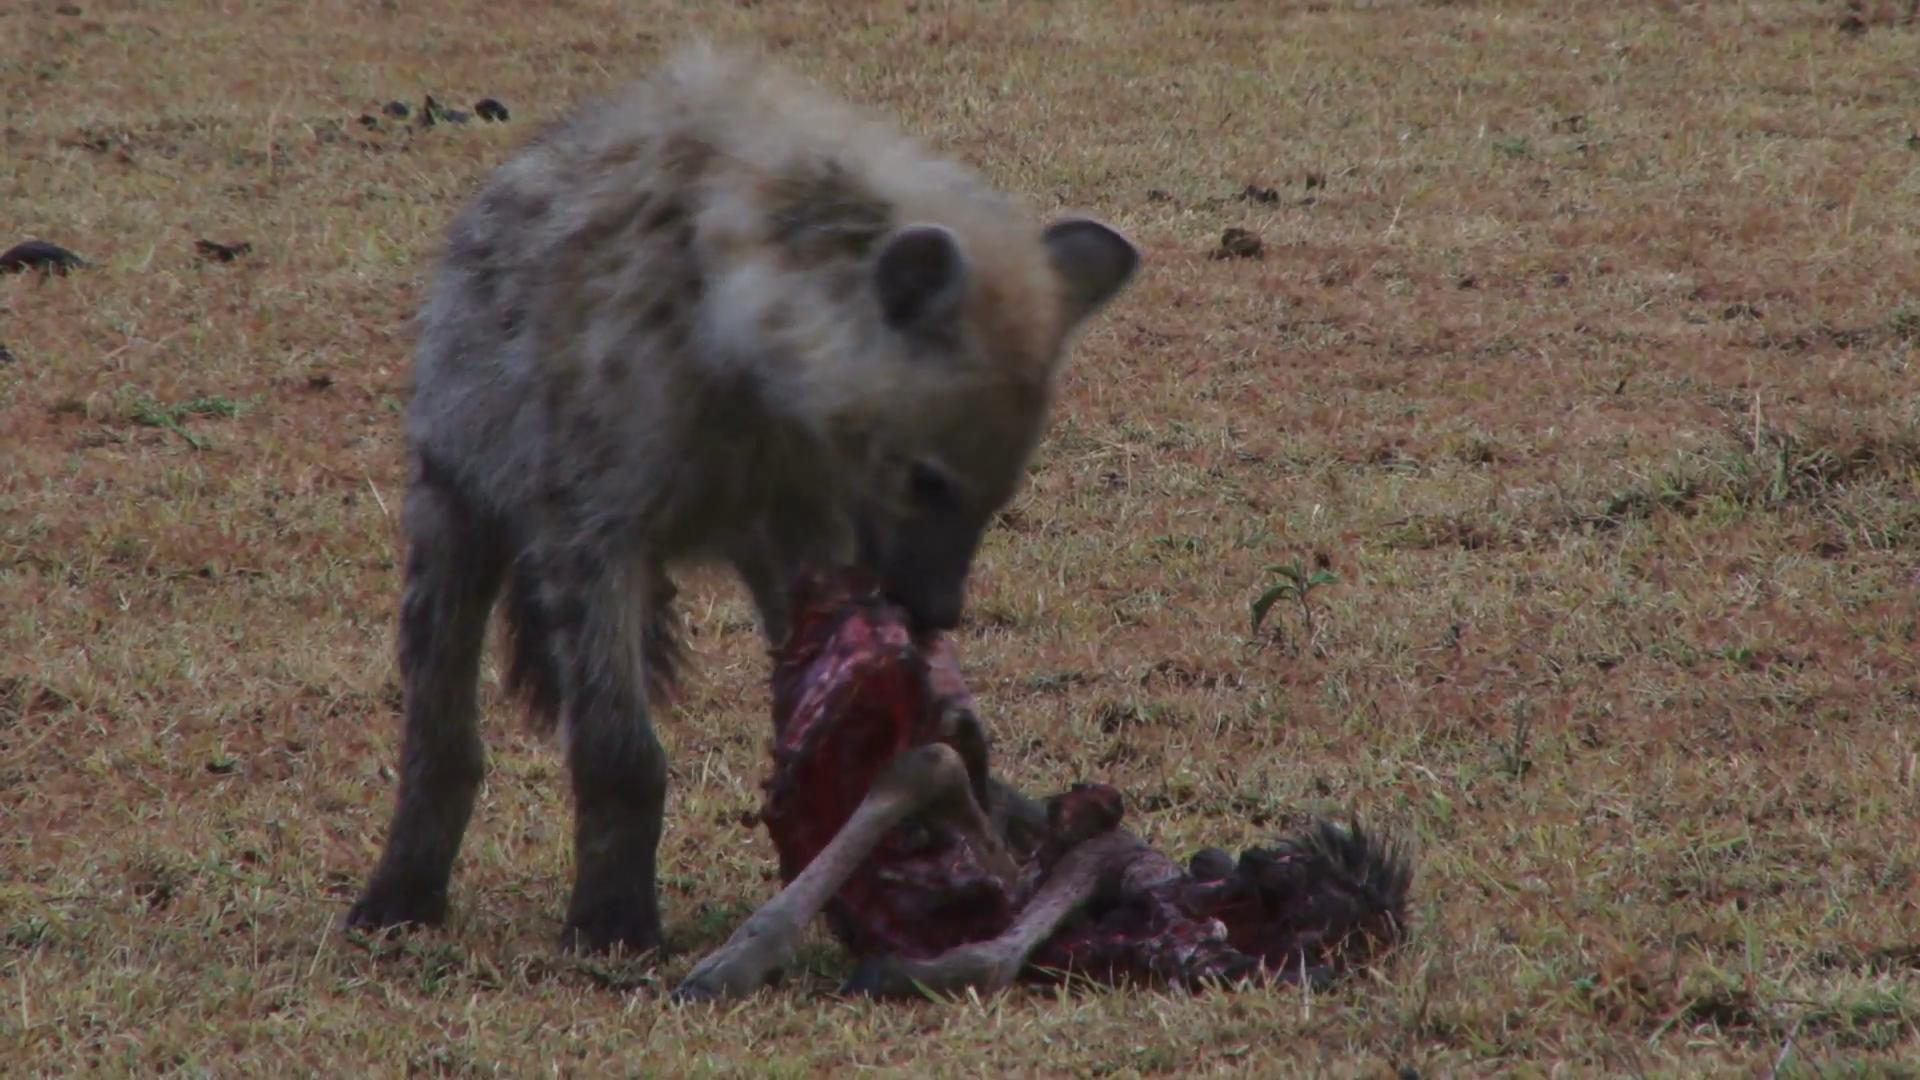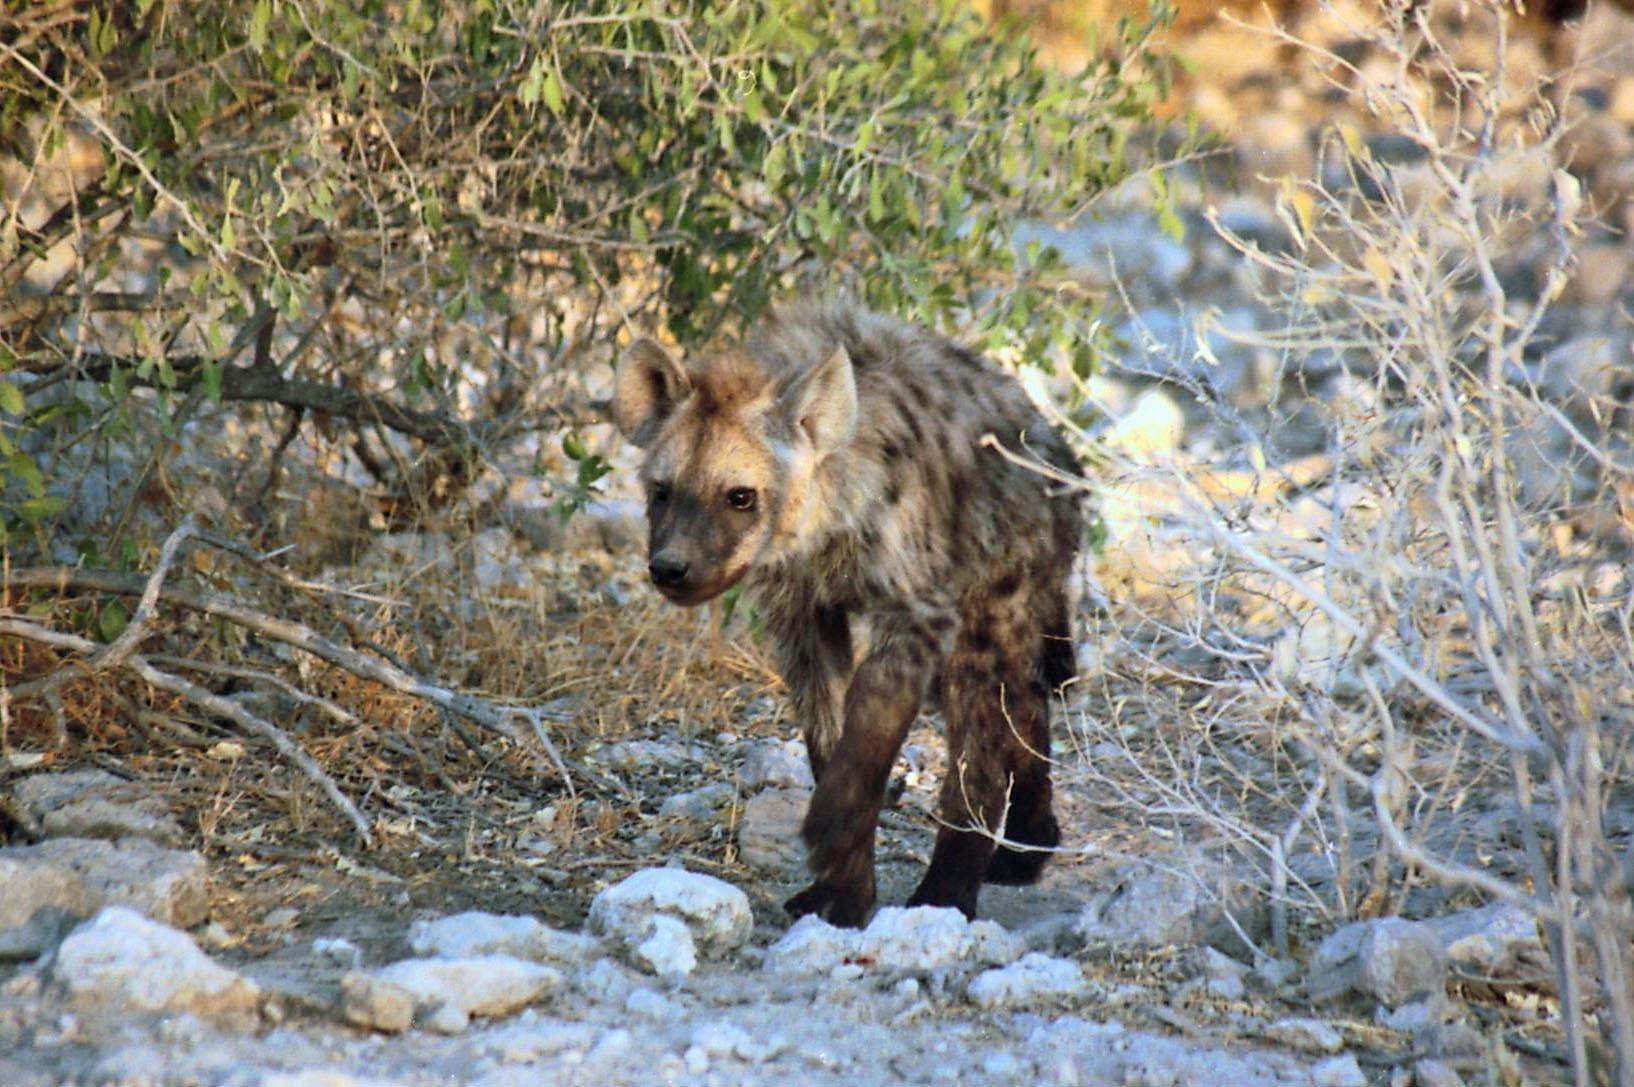The first image is the image on the left, the second image is the image on the right. Analyze the images presented: Is the assertion "Each image contains one hyena, and the hyena on the right has its head and body turned mostly forward, with its neck not raised higher than its shoulders." valid? Answer yes or no. Yes. 